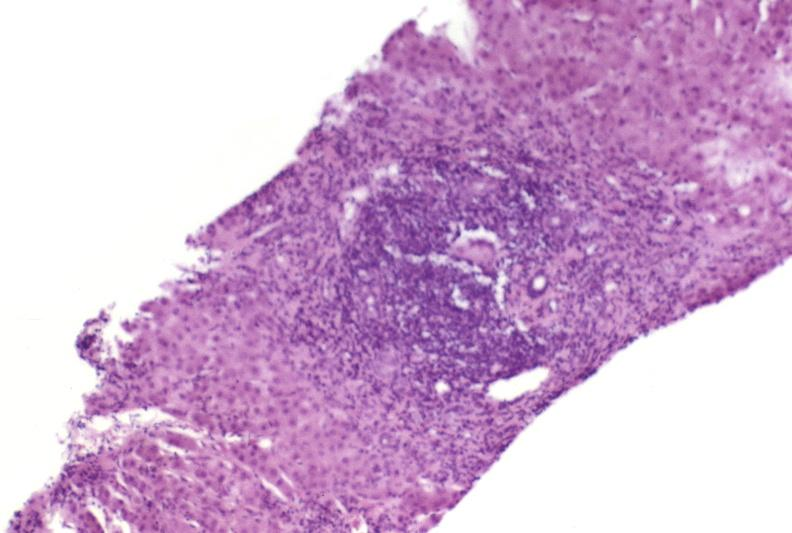what is present?
Answer the question using a single word or phrase. Liver 